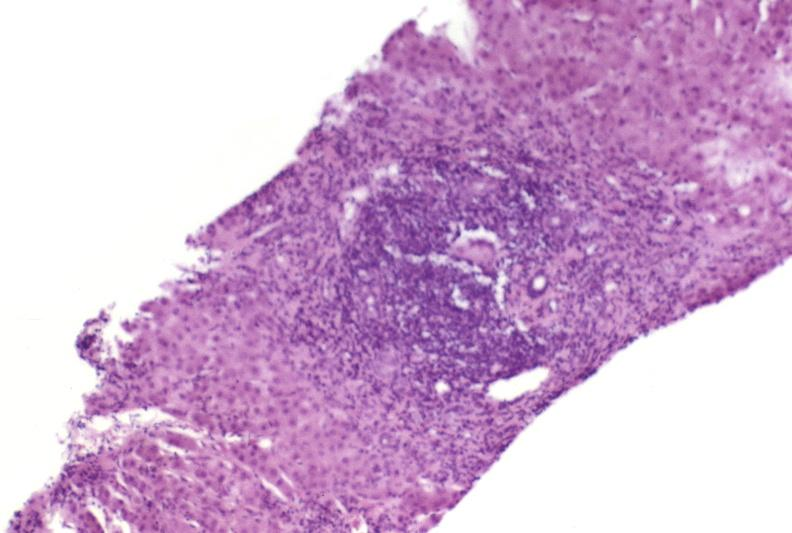what is present?
Answer the question using a single word or phrase. Liver 